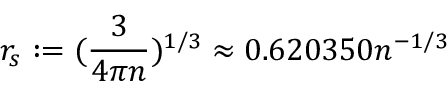<formula> <loc_0><loc_0><loc_500><loc_500>r _ { s } \colon = ( \frac { 3 } { 4 \pi n } ) ^ { 1 / 3 } \approx 0 . 6 2 0 3 5 0 n ^ { - 1 / 3 }</formula> 